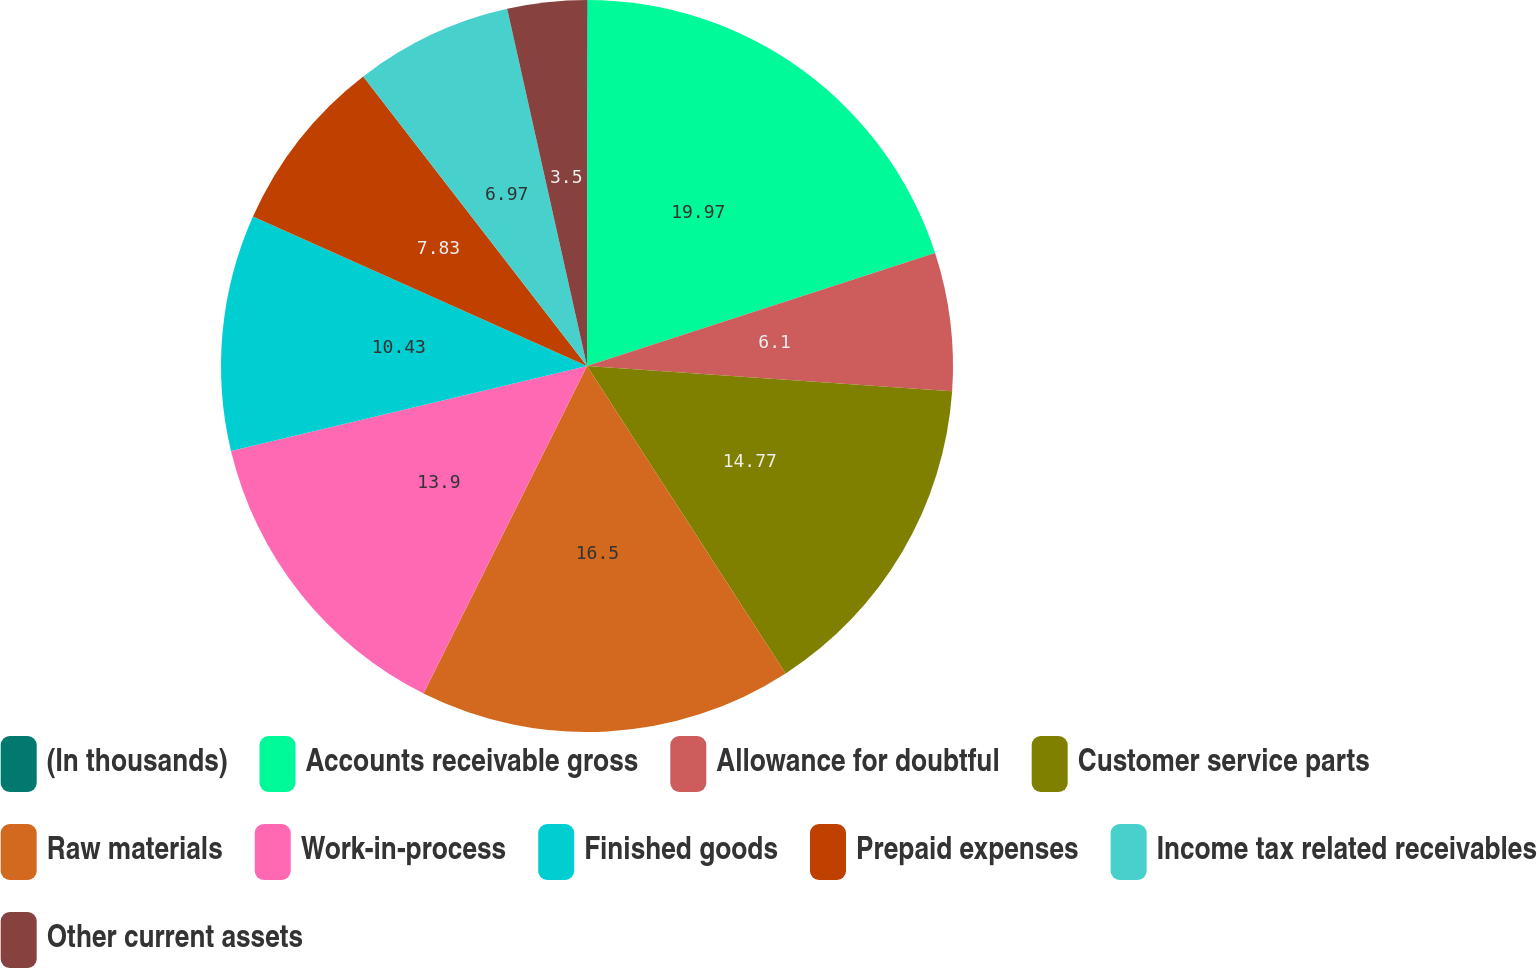<chart> <loc_0><loc_0><loc_500><loc_500><pie_chart><fcel>(In thousands)<fcel>Accounts receivable gross<fcel>Allowance for doubtful<fcel>Customer service parts<fcel>Raw materials<fcel>Work-in-process<fcel>Finished goods<fcel>Prepaid expenses<fcel>Income tax related receivables<fcel>Other current assets<nl><fcel>0.03%<fcel>19.97%<fcel>6.1%<fcel>14.77%<fcel>16.5%<fcel>13.9%<fcel>10.43%<fcel>7.83%<fcel>6.97%<fcel>3.5%<nl></chart> 